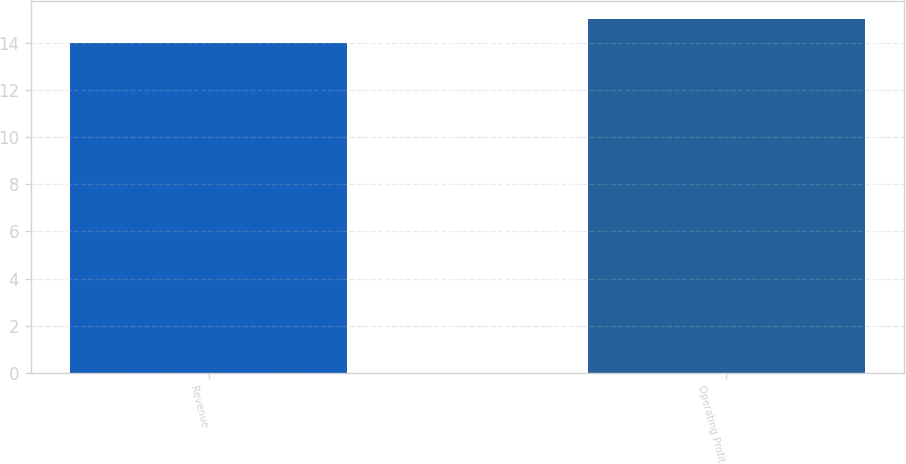Convert chart to OTSL. <chart><loc_0><loc_0><loc_500><loc_500><bar_chart><fcel>Revenue<fcel>Operating Profit<nl><fcel>14<fcel>15<nl></chart> 